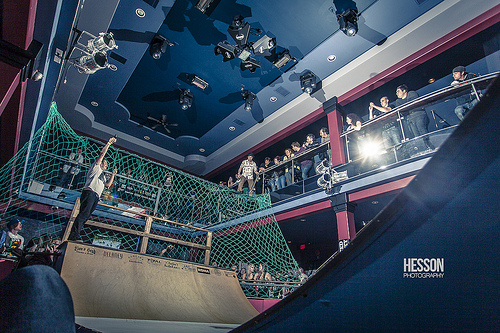<image>
Is the light on the net? No. The light is not positioned on the net. They may be near each other, but the light is not supported by or resting on top of the net. 